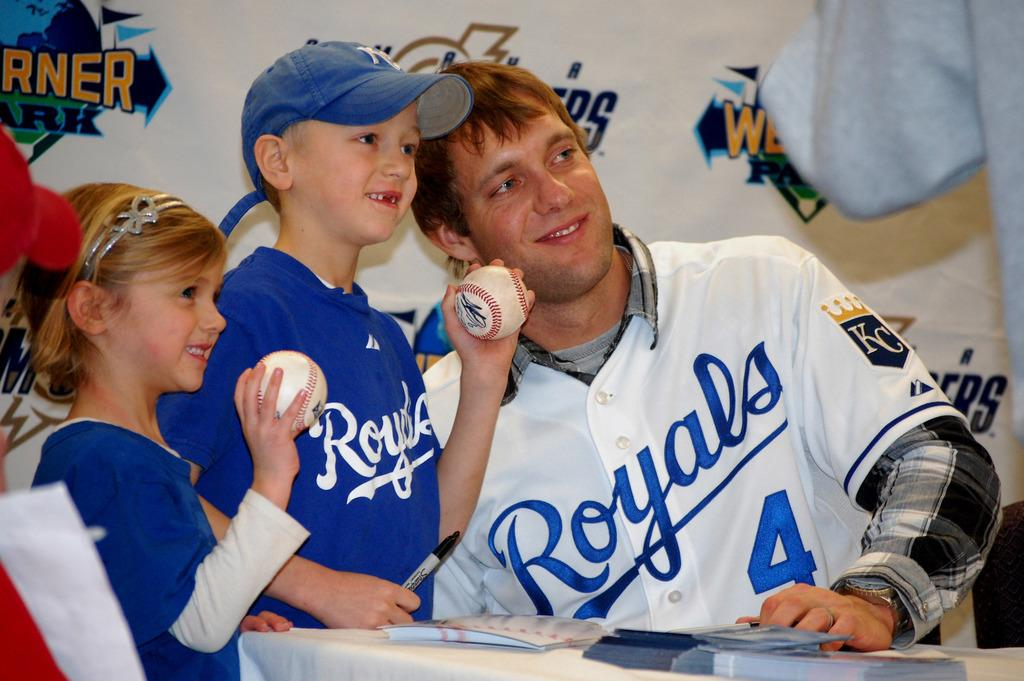<image>
Share a concise interpretation of the image provided. A man and some children wearing royals jerseys. 